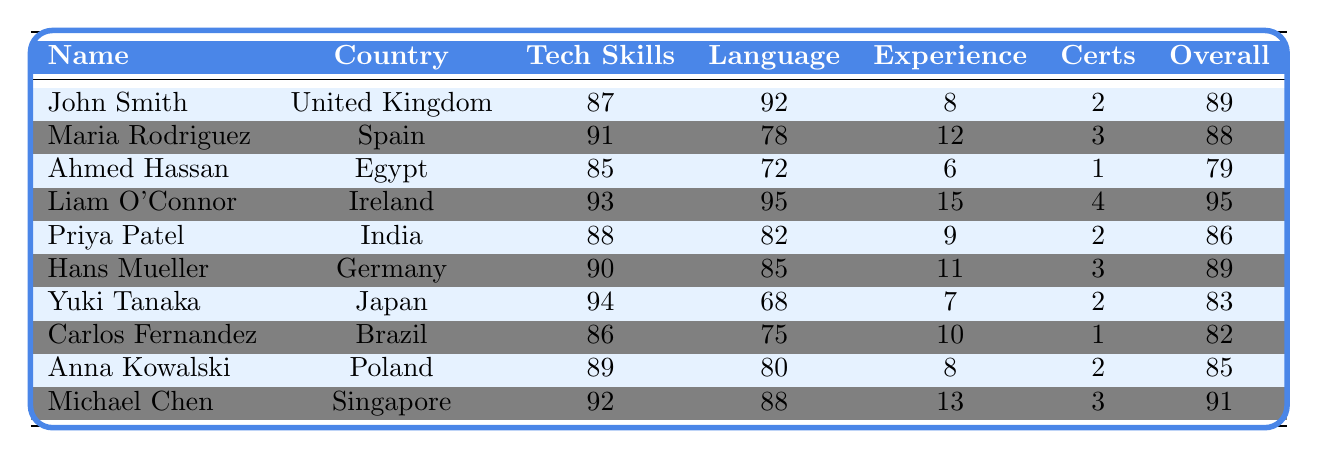What is the overall score of Liam O'Connor? Liam O'Connor's overall score is listed under the "Overall" column next to his name. The value is 95.
Answer: 95 Which applicant has the highest technical skills score? By comparing the "Tech Skills" column, Liam O'Connor has the highest score at 93, as all other scores are lower.
Answer: Liam O'Connor What is the average language proficiency score of all applicants? To calculate the average, sum all the language proficiency scores (92 + 78 + 72 + 95 + 82 + 85 + 68 + 75 + 80 + 88 = 915) and divide by the number of applicants (10). 915/10 = 91.5.
Answer: 91.5 Does Maria Rodriguez have more work experience than Ahmed Hassan? Comparing the "Work Experience" column, Maria Rodriguez has 12 years, and Ahmed Hassan has 6 years. Since 12 is greater than 6, Maria does have more experience.
Answer: Yes What is the difference between the overall scores of John Smith and Priya Patel? To find the difference, subtract Priya Patel's overall score (86) from John Smith's overall score (89): 89 - 86 = 3.
Answer: 3 Which applicant has the lowest overall score, and what is that score? By reviewing the "Overall" column, Ahmed Hassan has the lowest overall score listed at 79.
Answer: Ahmed Hassan, 79 How many applicants have an overall score above 90? By reviewing the "Overall" column, there are three applicants with scores above 90: Liam O'Connor (95), Michael Chen (91), and John Smith (89). Thus, the answer is three.
Answer: 2 Is Priya Patel's technical skills score higher than that of Carlos Fernandez? Looking at the "Tech Skills" column, Priya Patel's score is 88, and Carlos Fernandez's score is 86. Since 88 is greater than 86, Priya has a higher score.
Answer: Yes What is the total number of certifications held by all applicants combined? To find the total certifications, add up all the values in the "Certs" column (2 + 3 + 1 + 4 + 2 + 3 + 2 + 1 + 2 + 3 = 24).
Answer: 24 Which country has the applicant with the second-highest overall score, and what is that score? By examining the "Overall" column, Liam O'Connor has the highest score at 95. The second-highest score is Michael Chen with 91, who is from Singapore.
Answer: Singapore, 91 